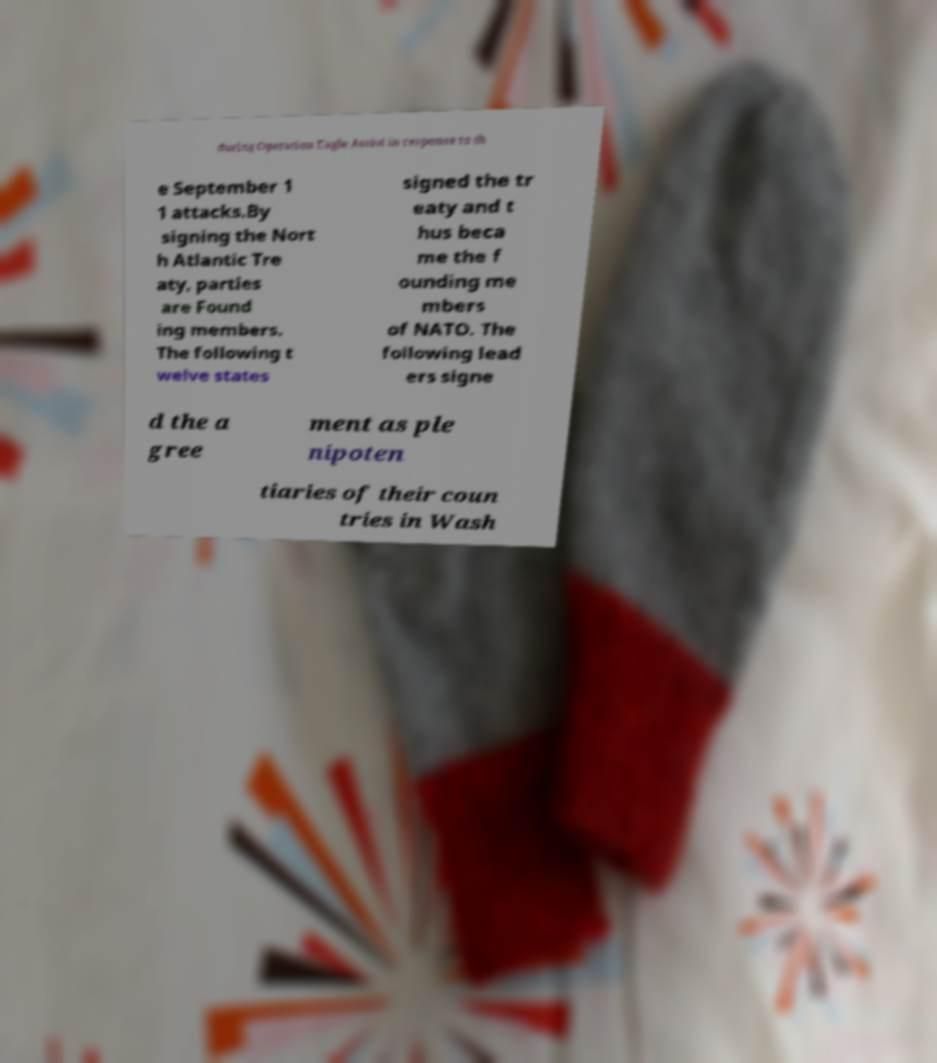What messages or text are displayed in this image? I need them in a readable, typed format. during Operation Eagle Assist in response to th e September 1 1 attacks.By signing the Nort h Atlantic Tre aty, parties are Found ing members. The following t welve states signed the tr eaty and t hus beca me the f ounding me mbers of NATO. The following lead ers signe d the a gree ment as ple nipoten tiaries of their coun tries in Wash 